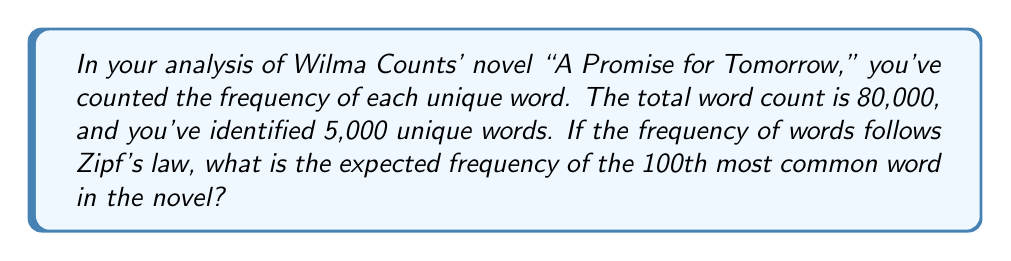Solve this math problem. To solve this problem, we need to understand and apply Zipf's law, which is often used in linguistic analysis. Zipf's law states that the frequency of any word is inversely proportional to its rank in the frequency table. Mathematically, this can be expressed as:

$$f(k) = \frac{C}{k^s}$$

Where:
$f(k)$ is the frequency of a word with rank $k$
$C$ is a normalization constant
$s$ is a parameter close to 1 for natural languages

For this problem, we'll assume $s = 1$ for simplicity.

Steps to solve:

1) First, we need to find the constant $C$. We can do this using the fact that the sum of all frequencies must equal the total number of words:

   $$\sum_{k=1}^{N} f(k) = 80000$$

   Where $N = 5000$ (the number of unique words)

2) Substituting the Zipf's law formula:

   $$\sum_{k=1}^{5000} \frac{C}{k} = 80000$$

3) The left side of this equation is approximately equal to $C \cdot H_{5000}$, where $H_{5000}$ is the 5000th harmonic number. We can approximate this using the natural logarithm:

   $$C \cdot \ln(5000) \approx 80000$$

4) Solving for $C$:

   $$C \approx \frac{80000}{\ln(5000)} \approx 9775.72$$

5) Now that we have $C$, we can find the frequency of the 100th word:

   $$f(100) = \frac{C}{100} \approx \frac{9775.72}{100} \approx 97.76$$

Therefore, the expected frequency of the 100th most common word is approximately 98 occurrences.
Answer: 98 occurrences 